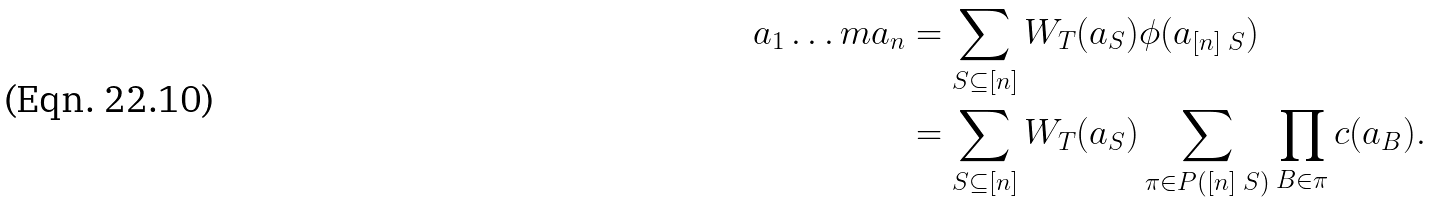Convert formula to latex. <formula><loc_0><loc_0><loc_500><loc_500>a _ { 1 } \dots m a _ { n } & = \sum _ { S \subseteq [ n ] } W _ { T } ( a _ { S } ) \phi ( a _ { [ n ] \ S } ) \\ & = \sum _ { S \subseteq [ n ] } W _ { T } ( a _ { S } ) \sum _ { \pi \in P ( [ n ] \ S ) } \prod _ { B \in \pi } c ( a _ { B } ) .</formula> 